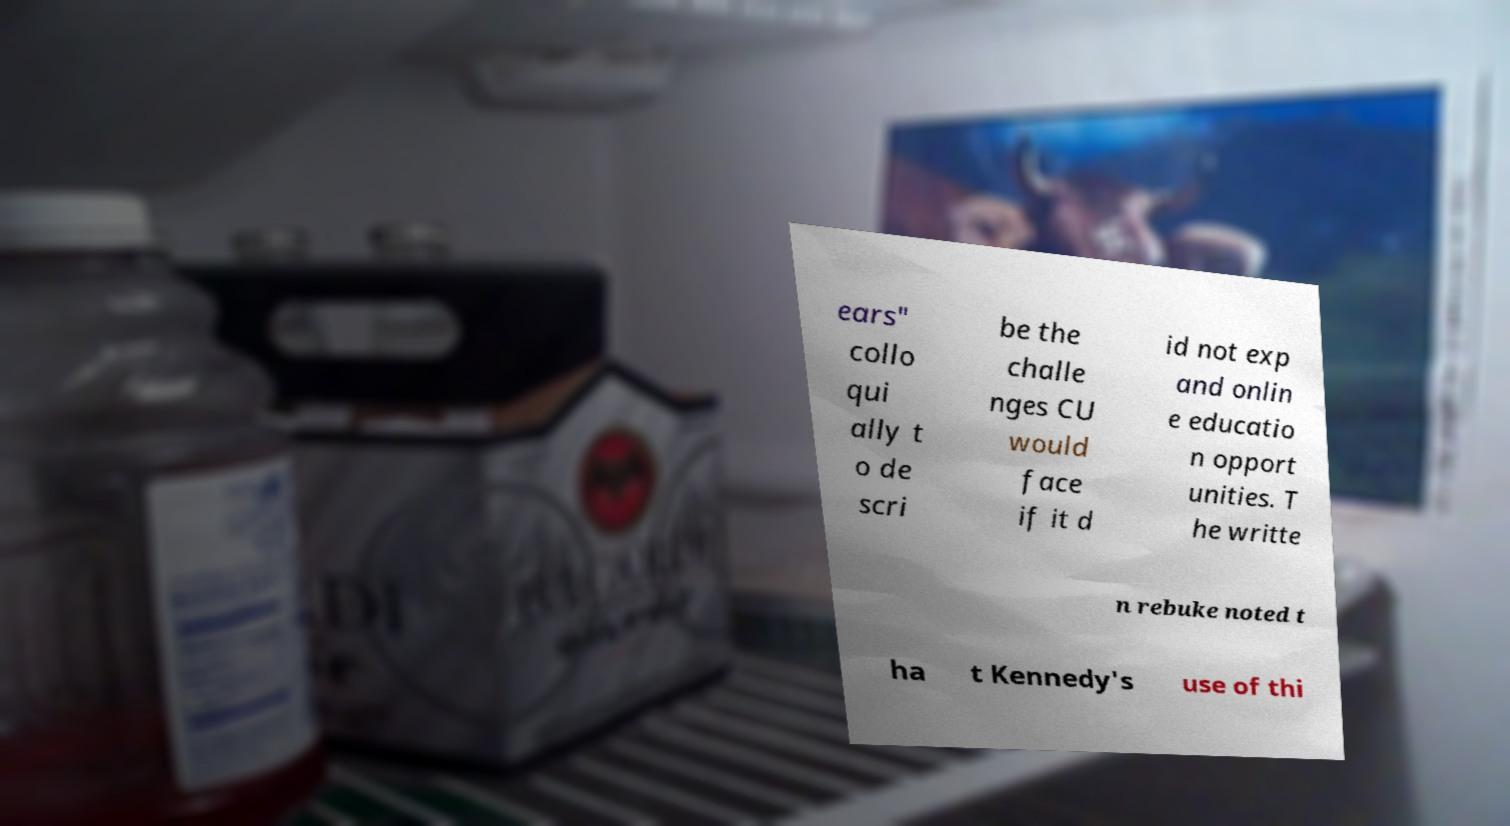Can you accurately transcribe the text from the provided image for me? ears" collo qui ally t o de scri be the challe nges CU would face if it d id not exp and onlin e educatio n opport unities. T he writte n rebuke noted t ha t Kennedy's use of thi 